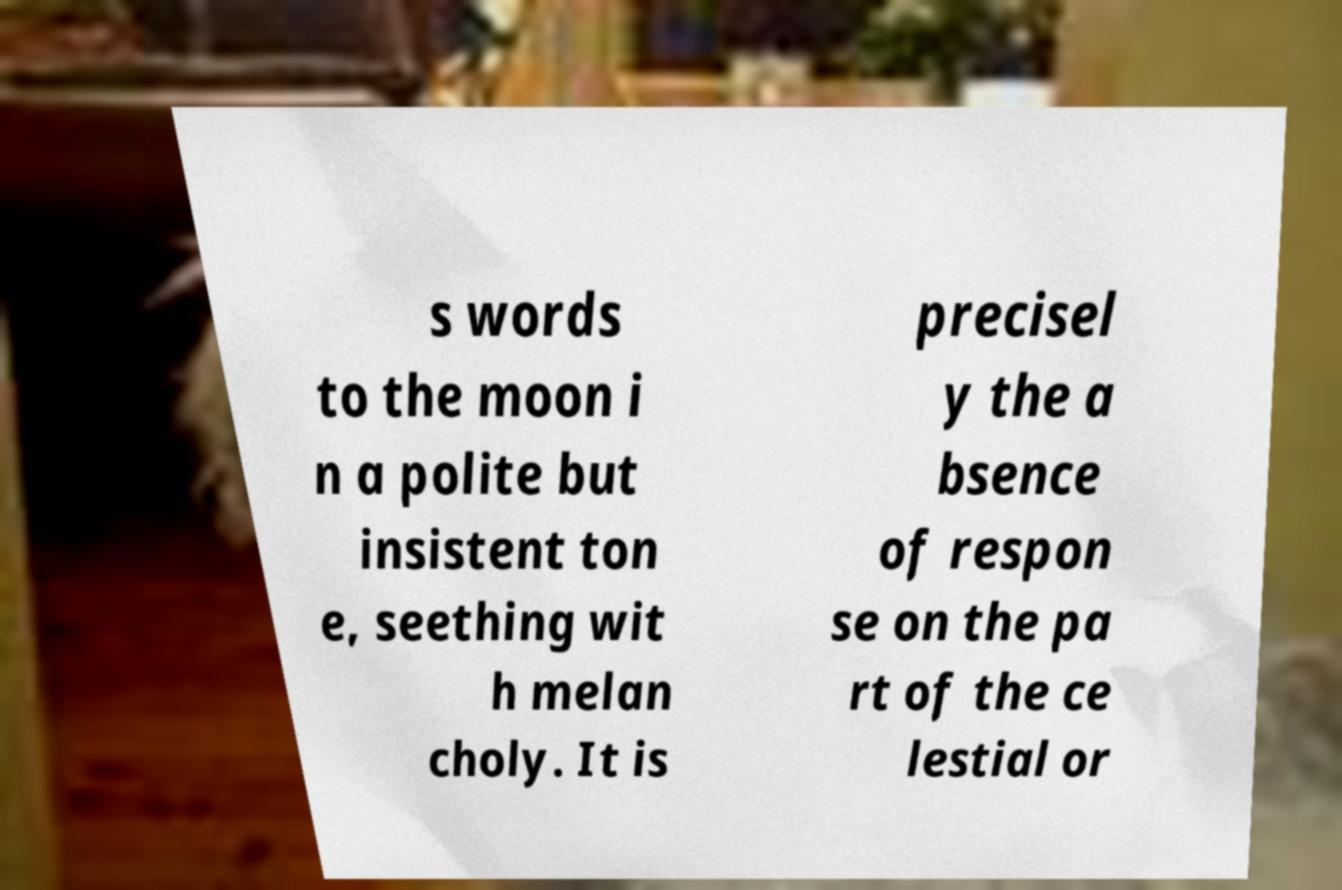For documentation purposes, I need the text within this image transcribed. Could you provide that? s words to the moon i n a polite but insistent ton e, seething wit h melan choly. It is precisel y the a bsence of respon se on the pa rt of the ce lestial or 